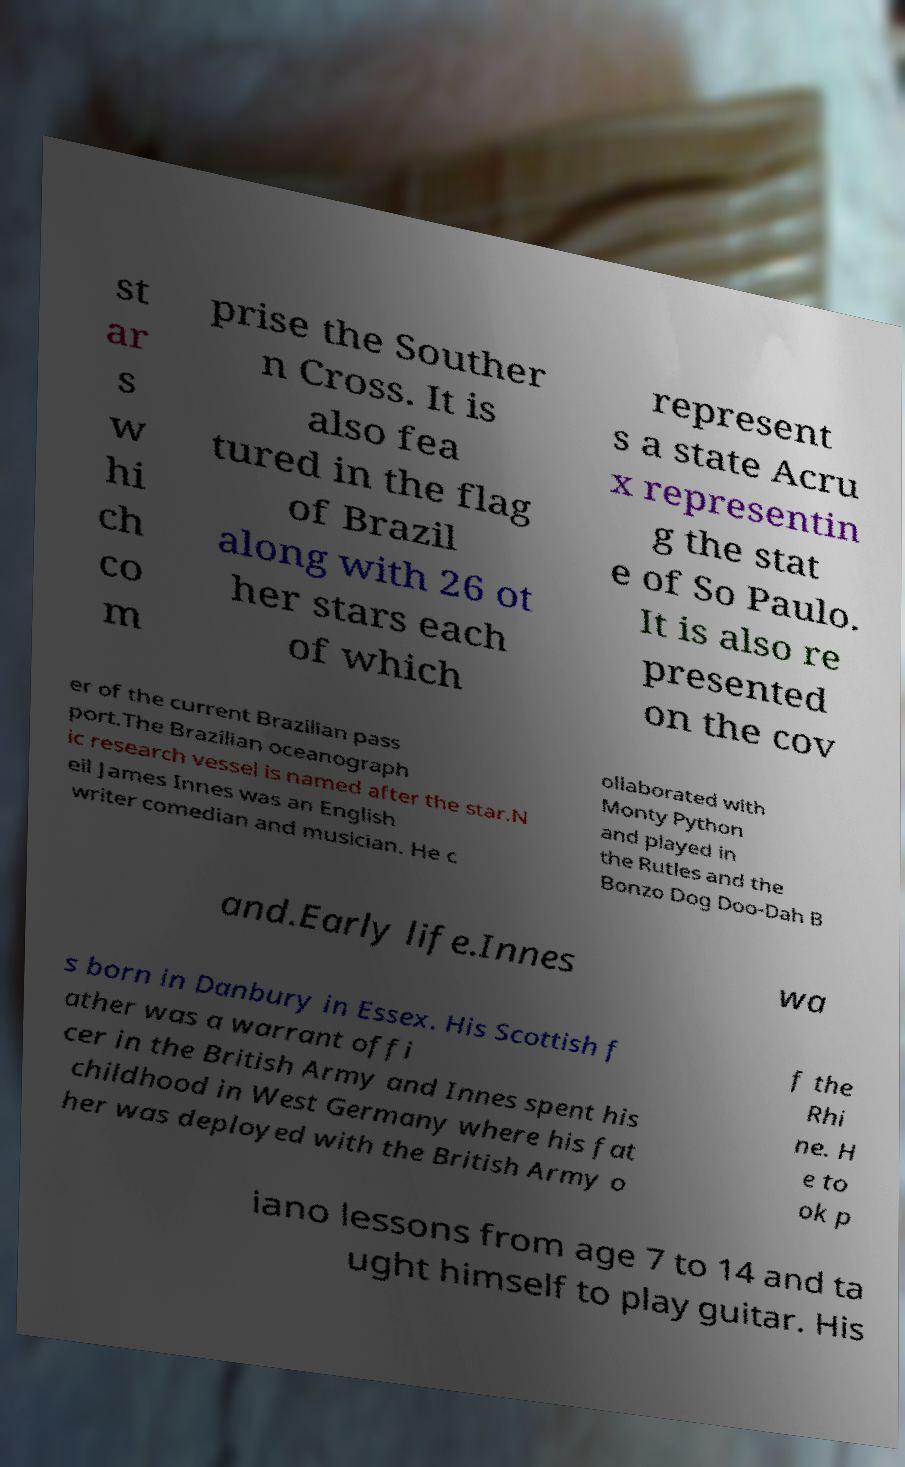Can you accurately transcribe the text from the provided image for me? st ar s w hi ch co m prise the Souther n Cross. It is also fea tured in the flag of Brazil along with 26 ot her stars each of which represent s a state Acru x representin g the stat e of So Paulo. It is also re presented on the cov er of the current Brazilian pass port.The Brazilian oceanograph ic research vessel is named after the star.N eil James Innes was an English writer comedian and musician. He c ollaborated with Monty Python and played in the Rutles and the Bonzo Dog Doo-Dah B and.Early life.Innes wa s born in Danbury in Essex. His Scottish f ather was a warrant offi cer in the British Army and Innes spent his childhood in West Germany where his fat her was deployed with the British Army o f the Rhi ne. H e to ok p iano lessons from age 7 to 14 and ta ught himself to play guitar. His 